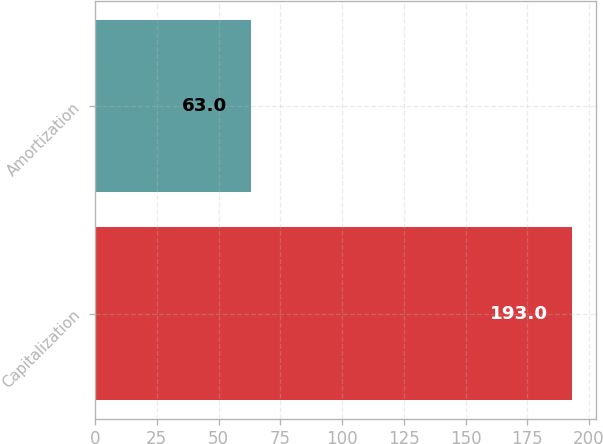<chart> <loc_0><loc_0><loc_500><loc_500><bar_chart><fcel>Capitalization<fcel>Amortization<nl><fcel>193<fcel>63<nl></chart> 